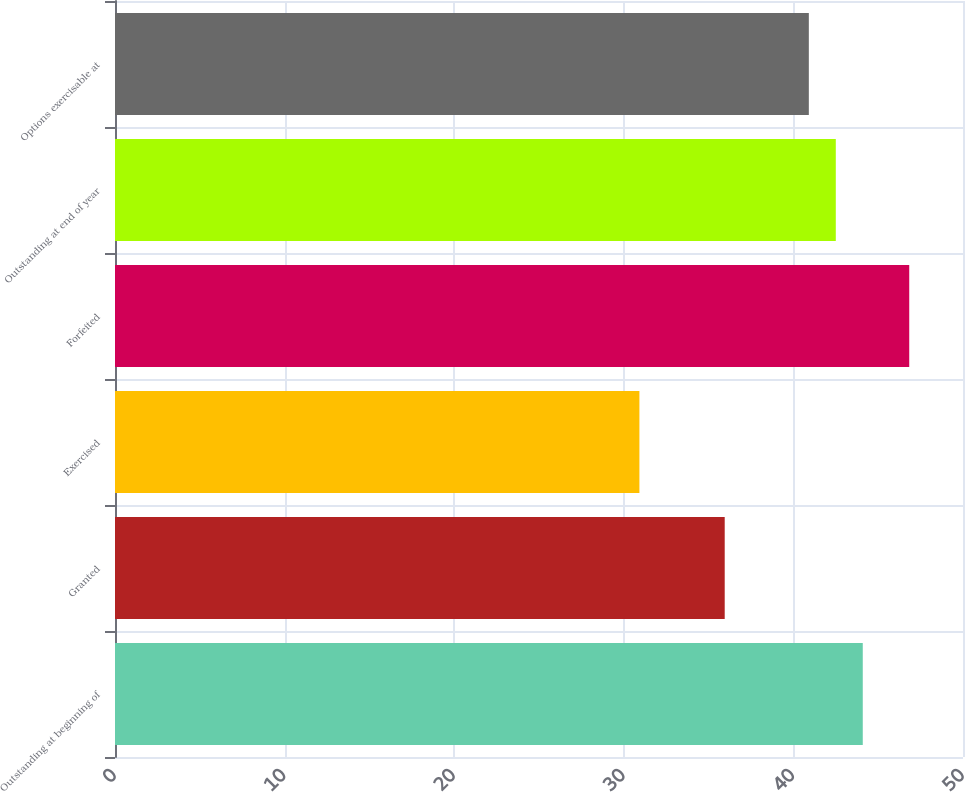<chart> <loc_0><loc_0><loc_500><loc_500><bar_chart><fcel>Outstanding at beginning of<fcel>Granted<fcel>Exercised<fcel>Forfeited<fcel>Outstanding at end of year<fcel>Options exercisable at<nl><fcel>44.09<fcel>35.95<fcel>30.92<fcel>46.83<fcel>42.5<fcel>40.91<nl></chart> 